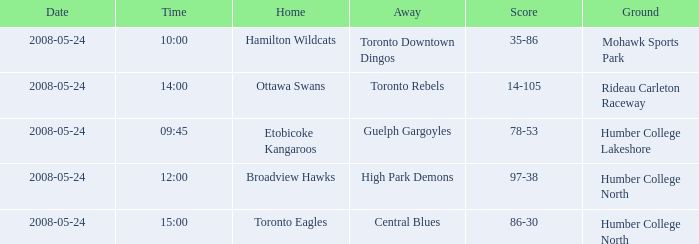On what day was the game that ended in a score of 97-38? 2008-05-24. 